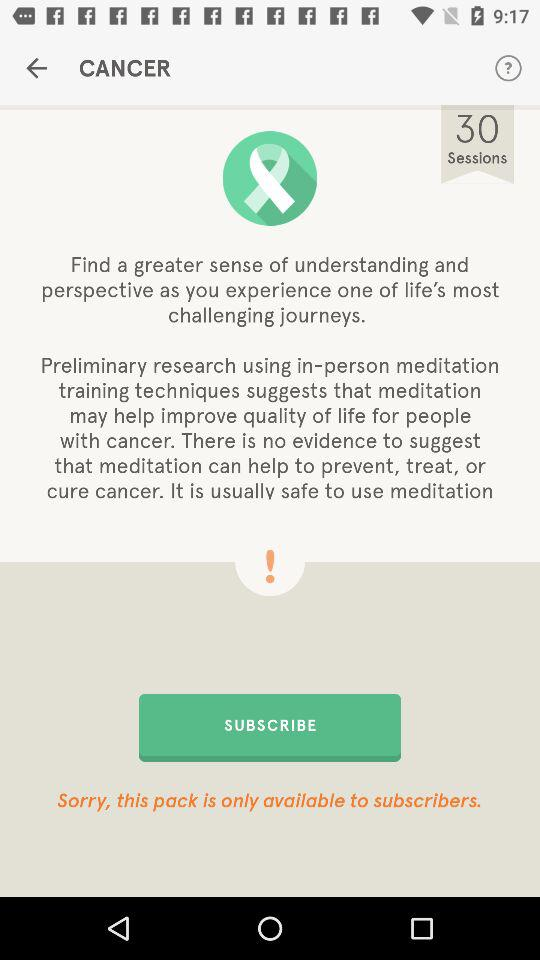How many sessions are included in this pack?
Answer the question using a single word or phrase. 30 